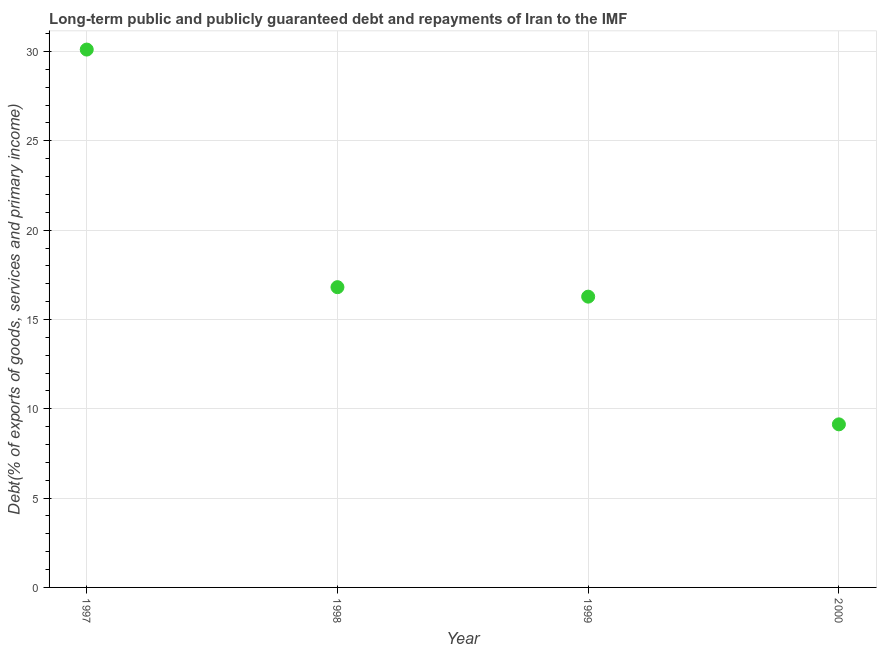What is the debt service in 1998?
Provide a short and direct response. 16.81. Across all years, what is the maximum debt service?
Keep it short and to the point. 30.11. Across all years, what is the minimum debt service?
Your response must be concise. 9.13. In which year was the debt service maximum?
Your answer should be compact. 1997. In which year was the debt service minimum?
Your answer should be very brief. 2000. What is the sum of the debt service?
Your response must be concise. 72.32. What is the difference between the debt service in 1997 and 2000?
Offer a terse response. 20.98. What is the average debt service per year?
Keep it short and to the point. 18.08. What is the median debt service?
Keep it short and to the point. 16.54. In how many years, is the debt service greater than 14 %?
Provide a succinct answer. 3. Do a majority of the years between 2000 and 1998 (inclusive) have debt service greater than 12 %?
Your response must be concise. No. What is the ratio of the debt service in 1999 to that in 2000?
Your answer should be compact. 1.78. Is the debt service in 1999 less than that in 2000?
Your response must be concise. No. Is the difference between the debt service in 1999 and 2000 greater than the difference between any two years?
Your answer should be compact. No. What is the difference between the highest and the second highest debt service?
Offer a terse response. 13.3. Is the sum of the debt service in 1997 and 1999 greater than the maximum debt service across all years?
Your response must be concise. Yes. What is the difference between the highest and the lowest debt service?
Keep it short and to the point. 20.98. Does the debt service monotonically increase over the years?
Offer a terse response. No. How many dotlines are there?
Your answer should be very brief. 1. What is the title of the graph?
Offer a terse response. Long-term public and publicly guaranteed debt and repayments of Iran to the IMF. What is the label or title of the Y-axis?
Keep it short and to the point. Debt(% of exports of goods, services and primary income). What is the Debt(% of exports of goods, services and primary income) in 1997?
Ensure brevity in your answer.  30.11. What is the Debt(% of exports of goods, services and primary income) in 1998?
Make the answer very short. 16.81. What is the Debt(% of exports of goods, services and primary income) in 1999?
Offer a terse response. 16.28. What is the Debt(% of exports of goods, services and primary income) in 2000?
Offer a very short reply. 9.13. What is the difference between the Debt(% of exports of goods, services and primary income) in 1997 and 1998?
Keep it short and to the point. 13.3. What is the difference between the Debt(% of exports of goods, services and primary income) in 1997 and 1999?
Offer a terse response. 13.83. What is the difference between the Debt(% of exports of goods, services and primary income) in 1997 and 2000?
Provide a succinct answer. 20.98. What is the difference between the Debt(% of exports of goods, services and primary income) in 1998 and 1999?
Your answer should be compact. 0.53. What is the difference between the Debt(% of exports of goods, services and primary income) in 1998 and 2000?
Make the answer very short. 7.68. What is the difference between the Debt(% of exports of goods, services and primary income) in 1999 and 2000?
Your response must be concise. 7.15. What is the ratio of the Debt(% of exports of goods, services and primary income) in 1997 to that in 1998?
Offer a very short reply. 1.79. What is the ratio of the Debt(% of exports of goods, services and primary income) in 1997 to that in 1999?
Your answer should be very brief. 1.85. What is the ratio of the Debt(% of exports of goods, services and primary income) in 1997 to that in 2000?
Ensure brevity in your answer.  3.3. What is the ratio of the Debt(% of exports of goods, services and primary income) in 1998 to that in 1999?
Offer a terse response. 1.03. What is the ratio of the Debt(% of exports of goods, services and primary income) in 1998 to that in 2000?
Offer a very short reply. 1.84. What is the ratio of the Debt(% of exports of goods, services and primary income) in 1999 to that in 2000?
Provide a short and direct response. 1.78. 